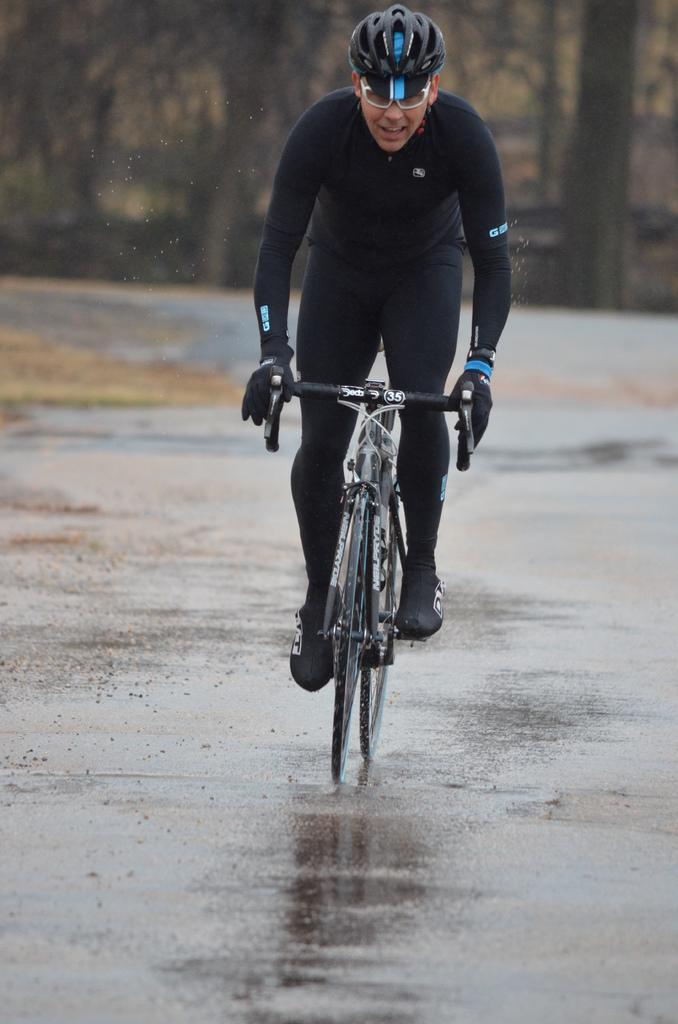What is the main subject of the image? There is a person in the image. What is the person wearing? The person is wearing a black dress. What activity is the person engaged in? The person is riding a bicycle. What is unusual about the road in the image? The road in the image is made of water. What type of vegetable is being used as a substitute for the road in the image? There is no vegetable being used as a substitute for the road in the image; the road is made of water. 